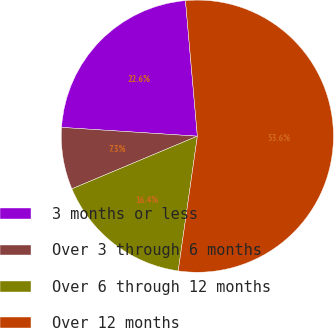Convert chart to OTSL. <chart><loc_0><loc_0><loc_500><loc_500><pie_chart><fcel>3 months or less<fcel>Over 3 through 6 months<fcel>Over 6 through 12 months<fcel>Over 12 months<nl><fcel>22.58%<fcel>7.35%<fcel>16.43%<fcel>53.64%<nl></chart> 